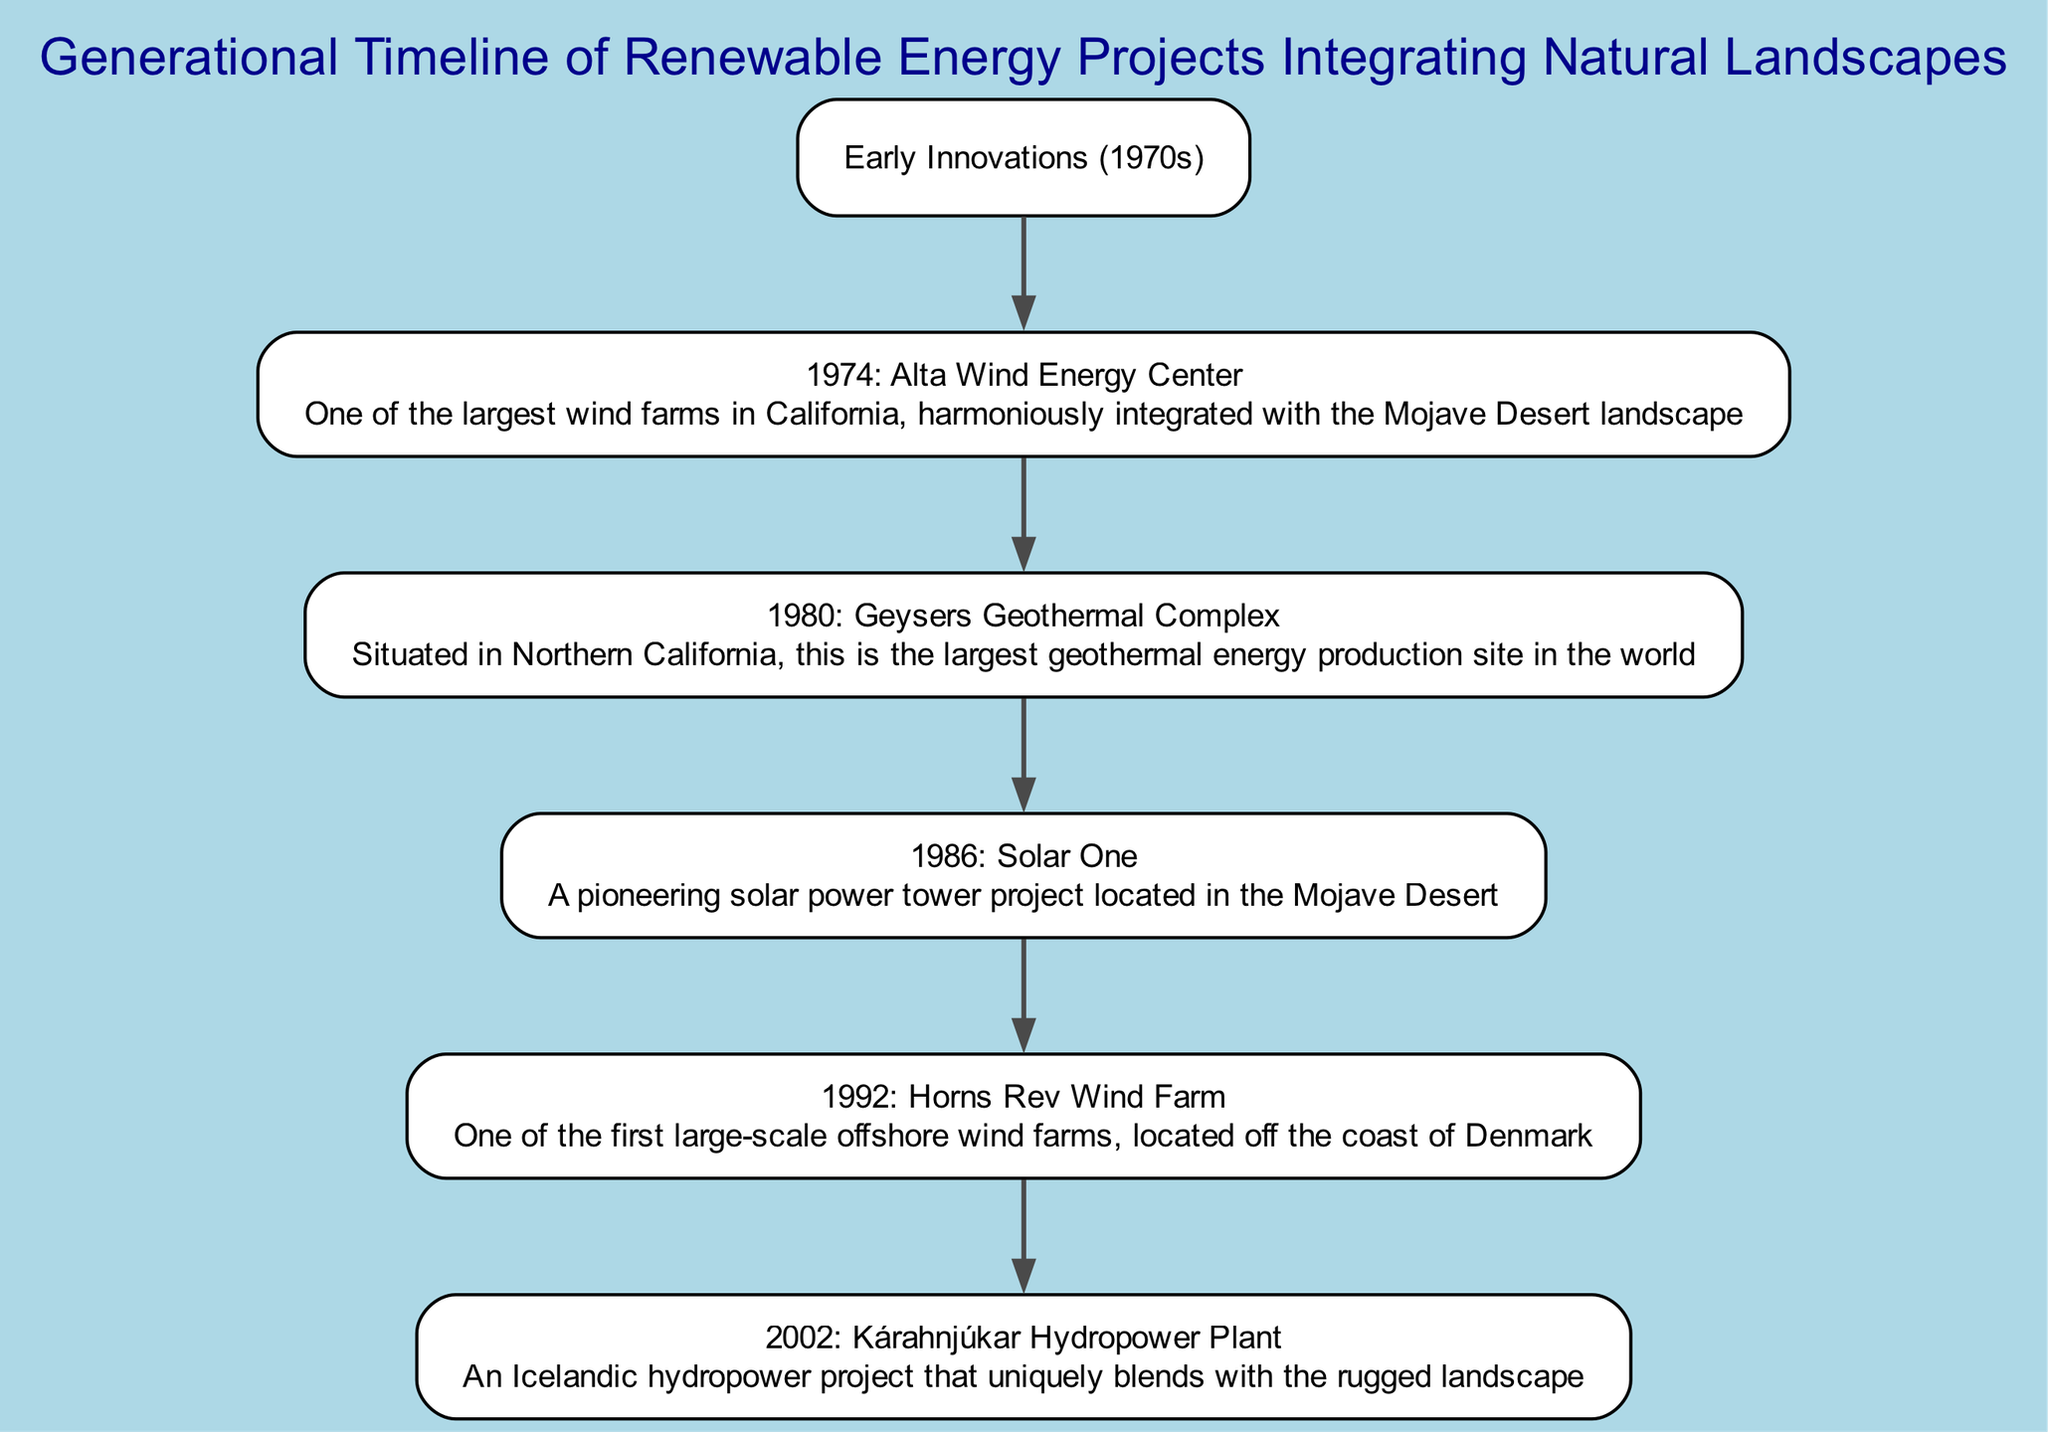What is the root node of the diagram? The root node represents the starting point of the family tree, which is clearly labeled as "Early Innovations (1970s)".
Answer: Early Innovations (1970s) How many major projects are listed under the "Early Innovations (1970s)" node? Counting the children of the root node indicates that there is one major project listed, which is the "1974: Alta Wind Energy Center".
Answer: 1 Which project is the first child of the "1974: Alta Wind Energy Center"? The first child of the "1974: Alta Wind Energy Center" is identified as "1980: Geysers Geothermal Complex".
Answer: 1980: Geysers Geothermal Complex What type of energy project is "1986: Solar One"? Looking at the details of "1986: Solar One", it is specified as a solar power tower project, indicating its type of renewable energy generation.
Answer: Solar power tower Which project is associated with the year 1992? The diagram indicates that the project linked with the year 1992 is "1992: Horns Rev Wind Farm".
Answer: 1992: Horns Rev Wind Farm How many levels are there in the diagram? The diagram can be analyzed from the root to its furthest child, illustrating that there are four distinct levels represented in the timeline.
Answer: 4 Which project is the most recent in this timeline? Reviewing the timeline, "2002: Kárahnjúkar Hydropower Plant" is identified as the most recent project listed among all nodes.
Answer: 2002: Kárahnjúkar Hydropower Plant What landscape is integrated with the "1980: Geysers Geothermal Complex"? The details indicate that "1980: Geysers Geothermal Complex" is situated in Northern California, harmonizing with its natural landscape.
Answer: Northern California How does "2002: Kárahnjúkar Hydropower Plant" uniquely blend with its location? The details state that this project, located in Iceland, uniquely blends with the rugged landscape, indicating a strong connection to geological features.
Answer: Rugged landscape 